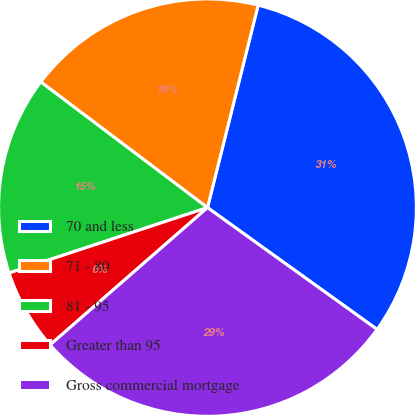Convert chart to OTSL. <chart><loc_0><loc_0><loc_500><loc_500><pie_chart><fcel>70 and less<fcel>71 - 80<fcel>81 - 95<fcel>Greater than 95<fcel>Gross commercial mortgage<nl><fcel>31.02%<fcel>18.61%<fcel>15.36%<fcel>6.35%<fcel>28.66%<nl></chart> 